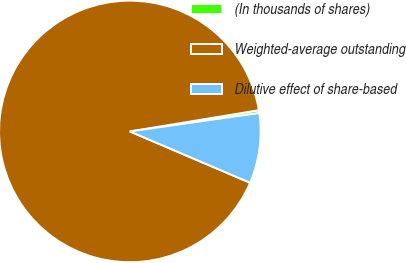Convert chart. <chart><loc_0><loc_0><loc_500><loc_500><pie_chart><fcel>(In thousands of shares)<fcel>Weighted-average outstanding<fcel>Dilutive effect of share-based<nl><fcel>0.35%<fcel>90.97%<fcel>8.67%<nl></chart> 